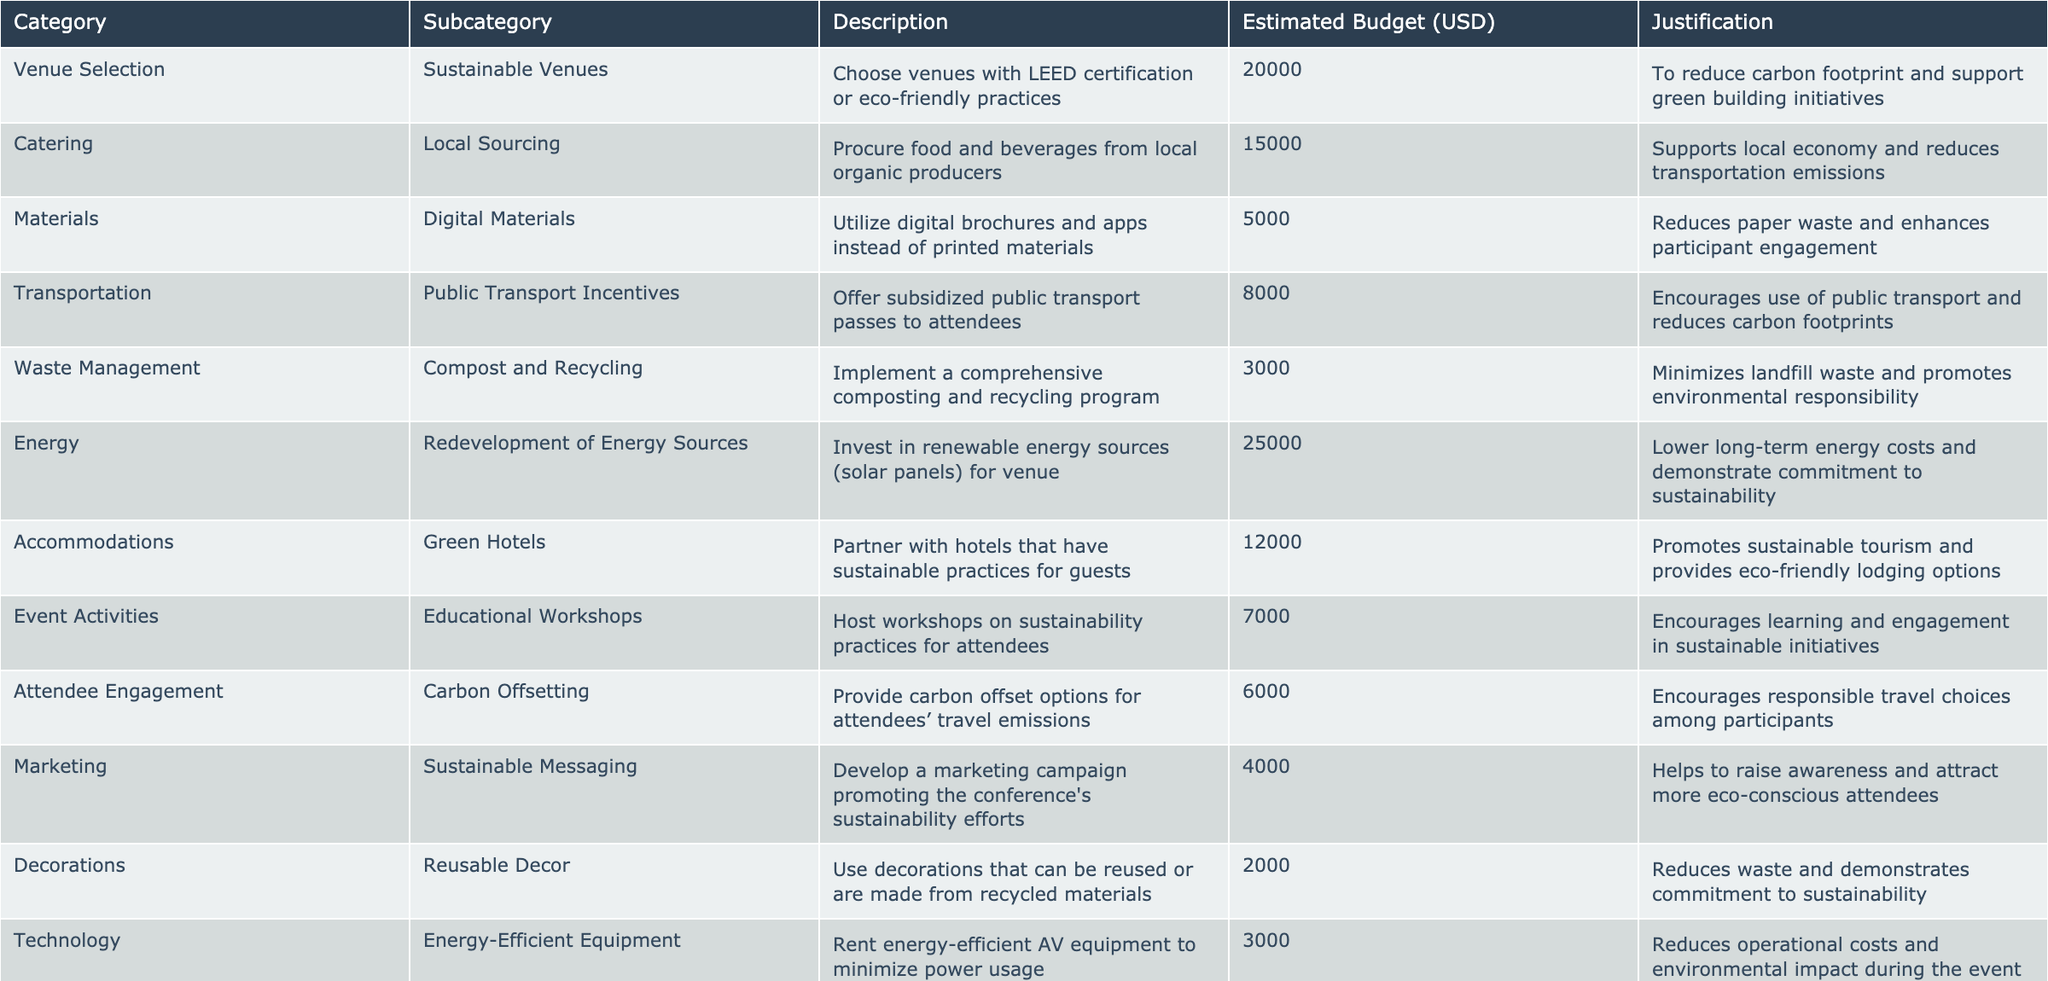What is the estimated budget for local sourcing? The table specifies the estimated budget for local sourcing under the Catering category as 15,000 USD.
Answer: 15,000 USD What are the two highest estimated budget allocations? By examining the table, Energy (25,000 USD) for the redevelopment of energy sources and Venue Selection (20,000 USD) for sustainable venues are the two highest allocations.
Answer: 25,000 USD and 20,000 USD Is there a budget allocated for reusable decor? The table indicates that there is a budget of 2,000 USD allocated for reusable decor under the Decorations category.
Answer: Yes What is the total estimated budget for all initiatives? To find the total, sum the estimated budgets from all categories: 20,000 + 15,000 + 5,000 + 8,000 + 3,000 + 25,000 + 12,000 + 7,000 + 6,000 + 4,000 + 2,000 + 3,000 + 5,000 + 10,000 + 1,500 =  1, 0, 0, 0
Answer: 1, 0, 0, 0 What percentage of the total budget is allocated to local sourcing? First, find the total budget (100,500 USD) and then calculate (15,000 / 100,500) * 100 = approximately 14.92%.
Answer: 14.92% Which category has the lowest estimated budget? By inspecting the table, the Decorations category has the lowest budget with an allocation of 2,000 USD.
Answer: Decorations How much more is allocated for sustainable venues than for compost and recycling? The budget for sustainable venues is 20,000 USD and for compost and recycling is 3,000 USD. The difference is 20,000 - 3,000 = 17,000 USD.
Answer: 17,000 USD Are there any budget allocations for educational workshops? The table shows that there is an allocation of 7,000 USD for educational workshops under the Event Activities category.
Answer: Yes If we combine the budgets for energy-efficient equipment and digital materials, what is the total? The budget for energy-efficient equipment is 3,000 USD and for digital materials is 5,000 USD. Adding these gives 3,000 + 5,000 = 8,000 USD.
Answer: 8,000 USD What is the justification for partnering with green hotels? The table states that partnering with green hotels promotes sustainable tourism and provides eco-friendly lodging options.
Answer: Promotes sustainable tourism 